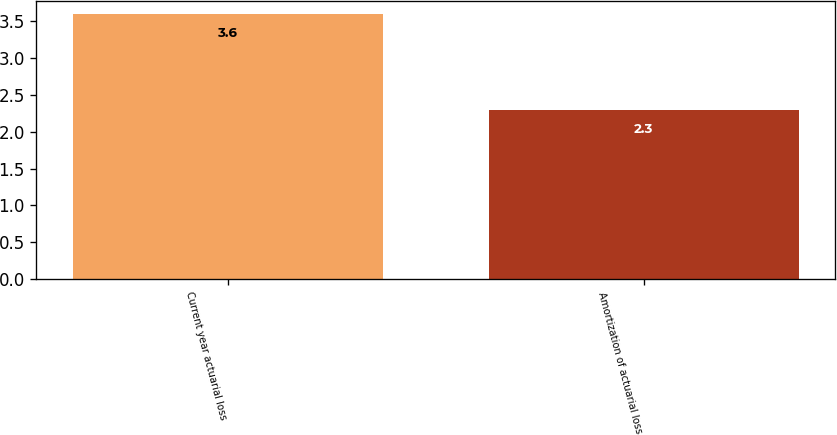Convert chart. <chart><loc_0><loc_0><loc_500><loc_500><bar_chart><fcel>Current year actuarial loss<fcel>Amortization of actuarial loss<nl><fcel>3.6<fcel>2.3<nl></chart> 